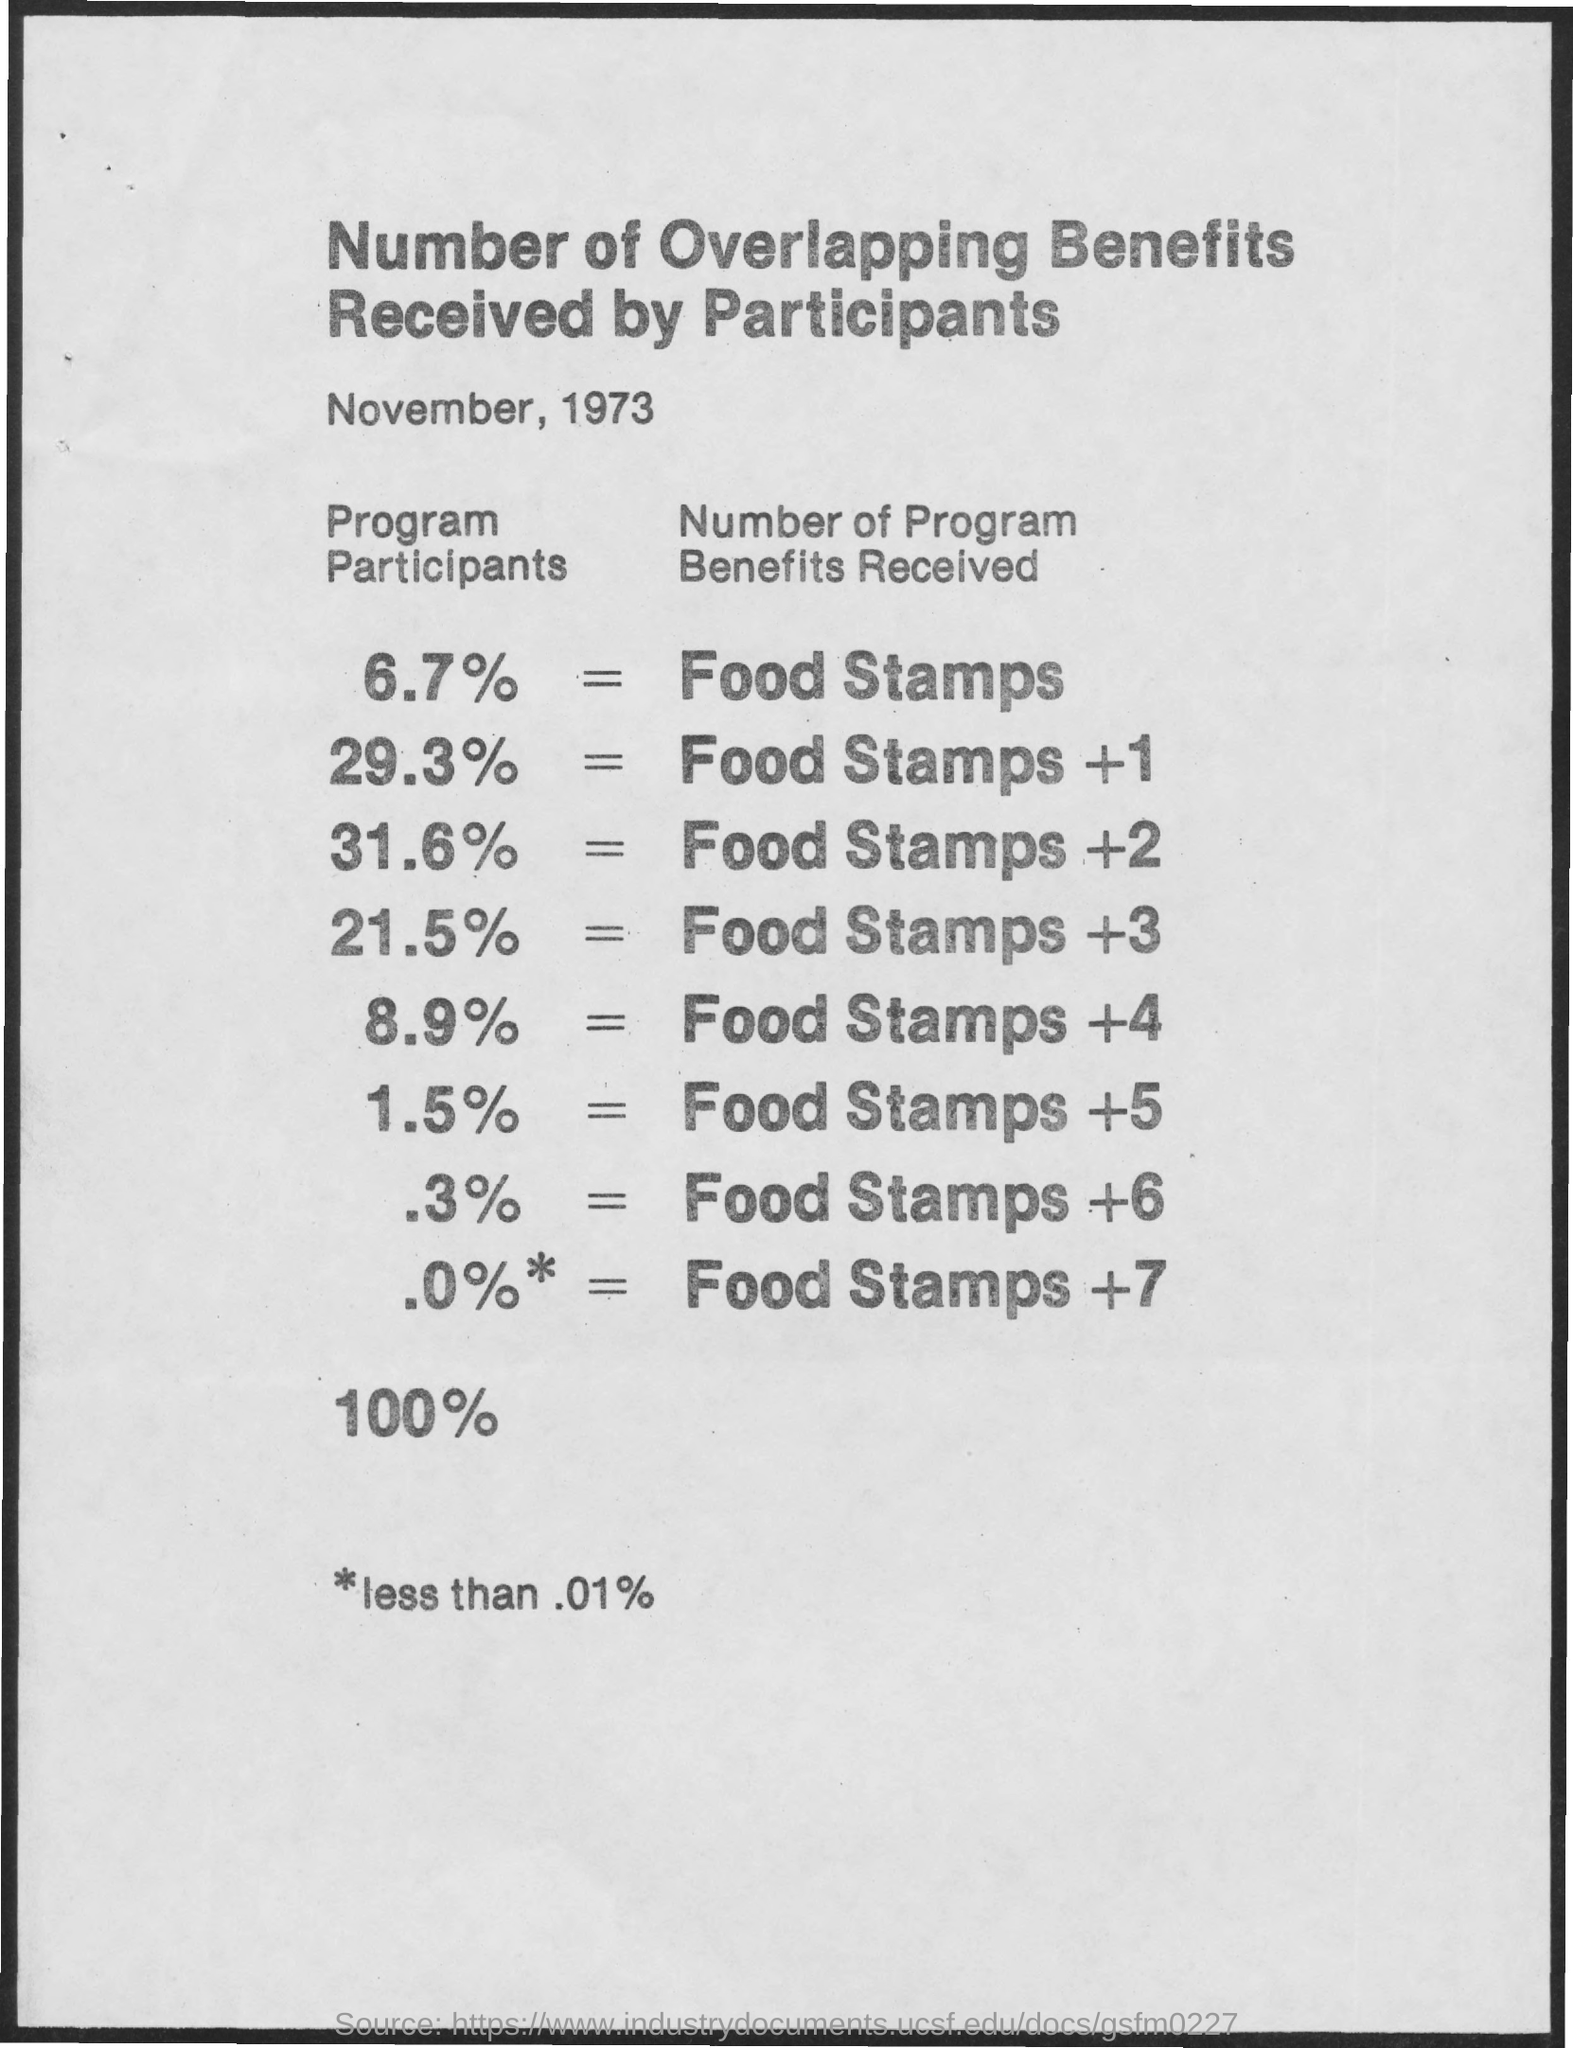Give some essential details in this illustration. This document titles the number of overlapping benefits received by participants, providing a comprehensive analysis of the subject matter. In the program, 31.6% of participants received Food stamps and an additional two participants, for a total of 31.6% of participants receiving Food stamps. The document is dated November, 1973. 